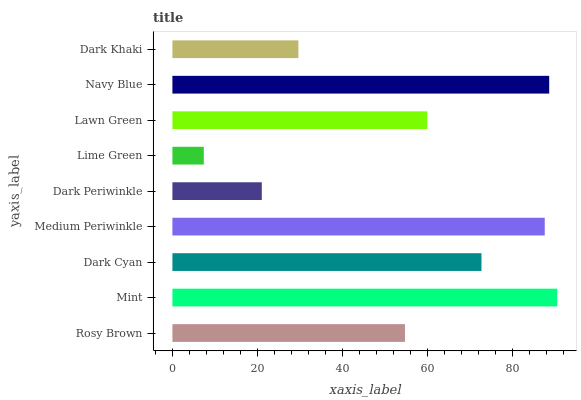Is Lime Green the minimum?
Answer yes or no. Yes. Is Mint the maximum?
Answer yes or no. Yes. Is Dark Cyan the minimum?
Answer yes or no. No. Is Dark Cyan the maximum?
Answer yes or no. No. Is Mint greater than Dark Cyan?
Answer yes or no. Yes. Is Dark Cyan less than Mint?
Answer yes or no. Yes. Is Dark Cyan greater than Mint?
Answer yes or no. No. Is Mint less than Dark Cyan?
Answer yes or no. No. Is Lawn Green the high median?
Answer yes or no. Yes. Is Lawn Green the low median?
Answer yes or no. Yes. Is Navy Blue the high median?
Answer yes or no. No. Is Navy Blue the low median?
Answer yes or no. No. 